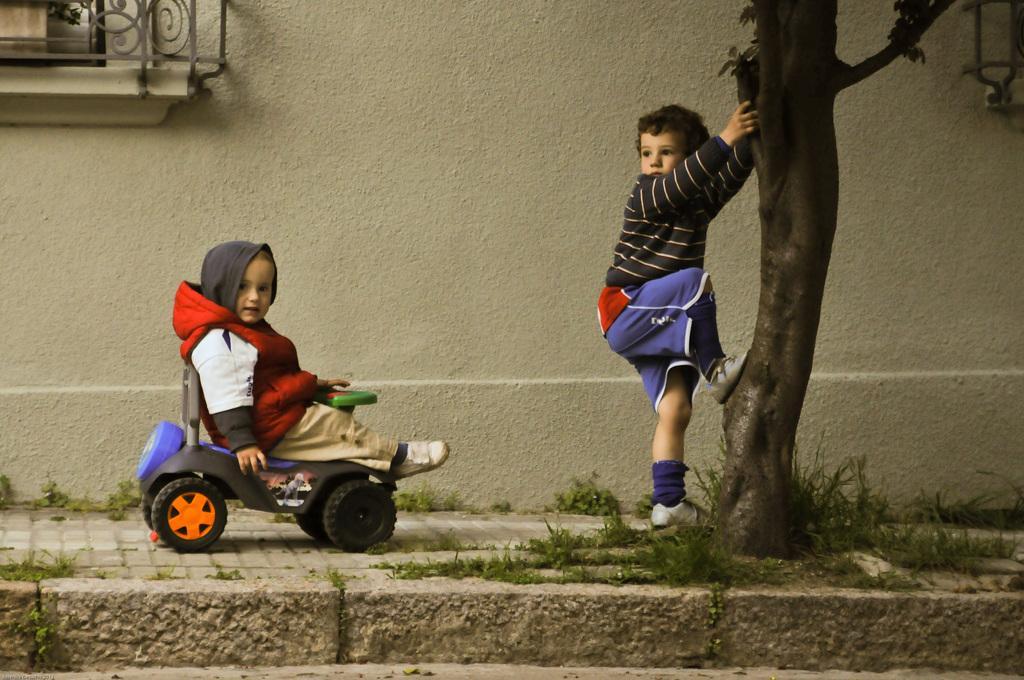Could you give a brief overview of what you see in this image? In this image, we can see two kids, one is standing and one is sitting in the toy car, in the background we can see a wall. 